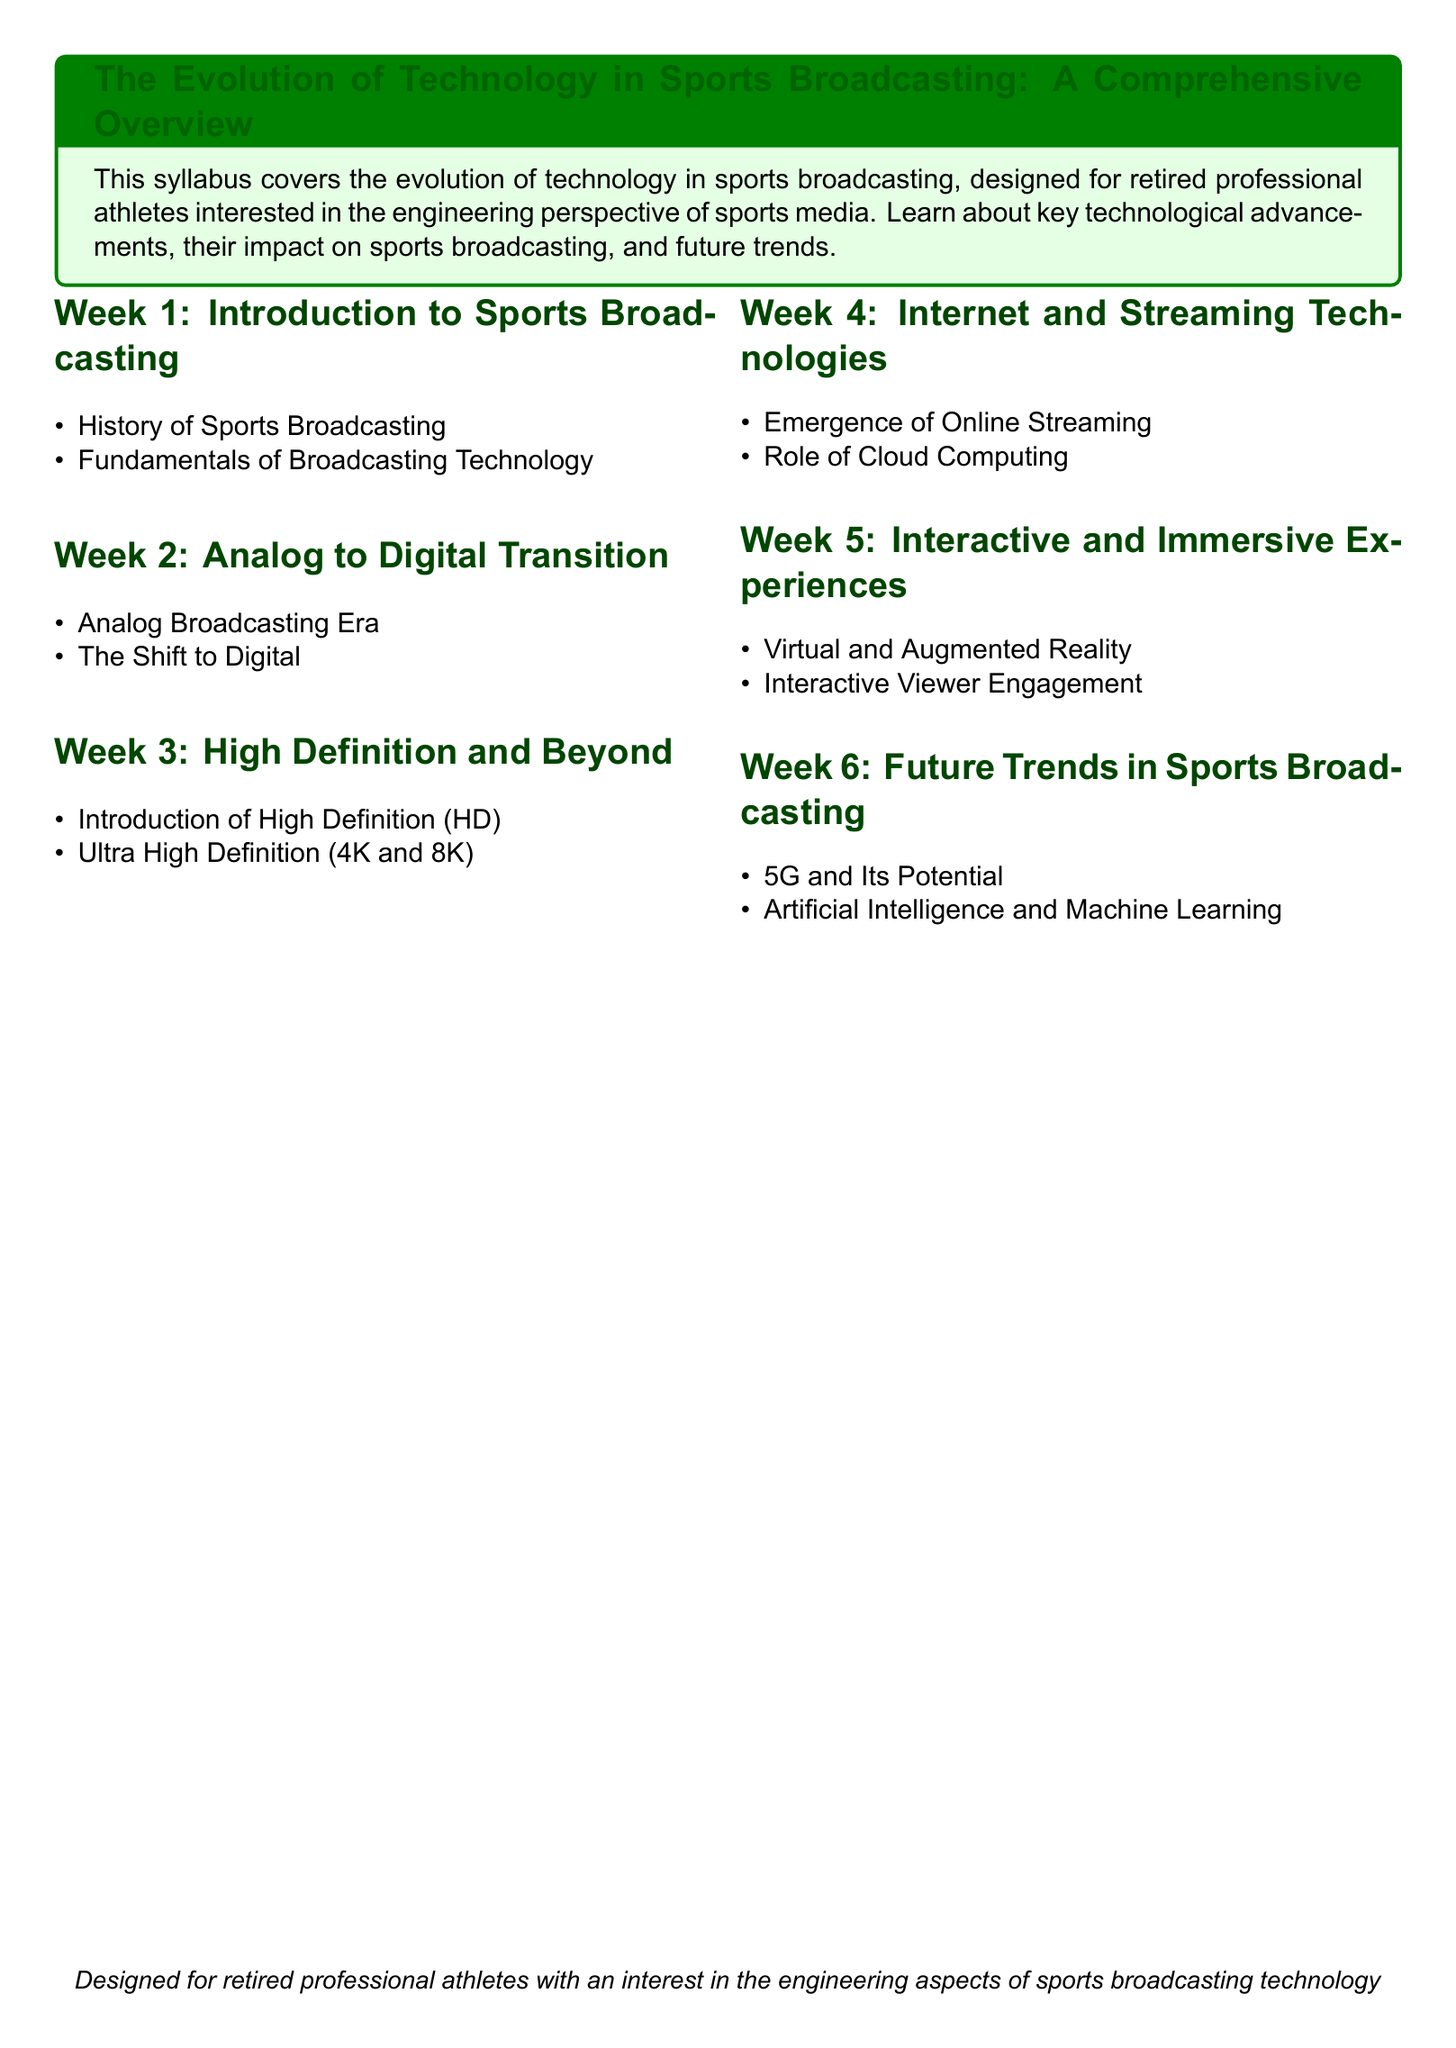What is the title of the syllabus? The title of the syllabus is provided at the top of the document in a prominent format.
Answer: The Evolution of Technology in Sports Broadcasting: A Comprehensive Overview How many weeks are covered in the syllabus? The syllabus outlines the content over a six-week period, as indicated in the weekly sections.
Answer: 6 What is covered in Week 2 of the syllabus? Week 2 focuses on the transition from an older broadcasting system to a modern one, covering two specific topics listed there.
Answer: Analog Broadcasting Era and The Shift to Digital What technology is introduced in Week 3? Week 3 specifically addresses advancements in video quality and resolution standards that have emerged over time.
Answer: High Definition (HD) and Ultra High Definition (4K and 8K) Which week focuses on future trends in sports broadcasting? The syllabus specifies which week is dedicated to discussing emerging technologies and predictions for the broadcast industry.
Answer: Week 6 What interactive technology is discussed in Week 5? The syllabus mentions specific technologies that enhance viewer engagement through unique experiences.
Answer: Virtual and Augmented Reality 